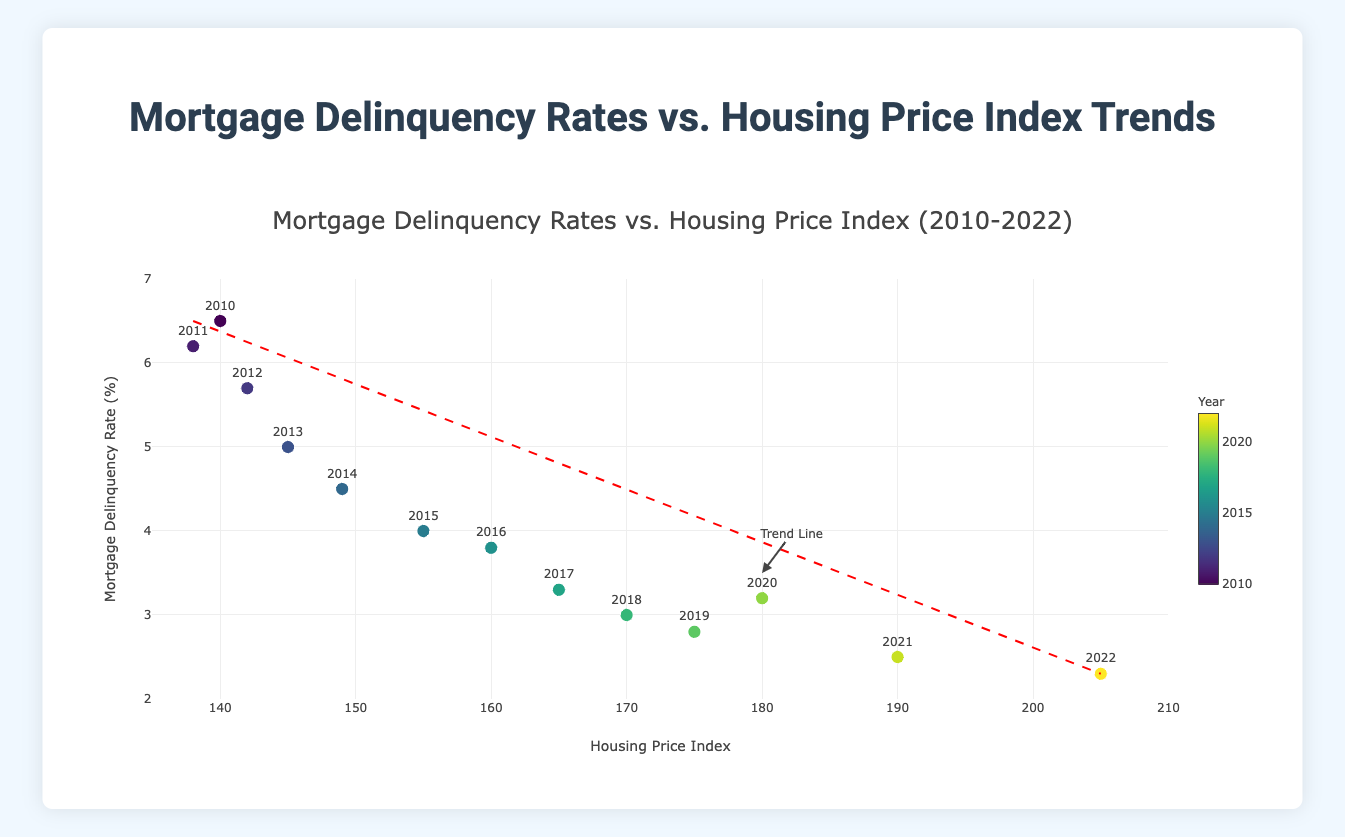What is the title of the figure? The title of the figure is usually located at the top and provides a clear description of what the plot represents. In this case, the title indicates that the figure shows the relationship between Mortgage Delinquency Rates and Housing Price Index Trends from 2010 to 2022.
Answer: Mortgage Delinquency Rates vs. Housing Price Index Trends How many data points are represented in the figure? By examining the number of markers on the scatter plot, we can count the distinct data points. Each marker corresponds to a year within the specified range.
Answer: 13 What is the Mortgage Delinquency Rate in 2016? Locate the data point corresponding to the year 2016, then read the value on the y-axis, which represents the Mortgage Delinquency Rate.
Answer: 3.8% How does the Housing Price Index change from 2010 to 2022? Identify the data points for the years 2010 and 2022. Then compare the x-axis values for these years to determine the change. The Housing Price Index increases from 140.0 in 2010 to 205.0 in 2022.
Answer: Increased Which year had the lowest Mortgage Delinquency Rate? Identify the data point that is the lowest on the y-axis, then refer to the corresponding year marked on the scatter plot.
Answer: 2022 What is the trend line showing about the relationship between Mortgage Delinquency Rates and Housing Price Index? The trend line is a dashed red line that gives the overall trend direction. It shows a downward slope from a high Mortgage Delinquency Rate to a lower one as the Housing Price Index increases, indicating an inverse relationship.
Answer: Inverse relationship In which year does the Housing Price Index first exceed 150? Identify the point where the x-axis value exceeds 150 for the first time, then find the corresponding year. This occurs at the data point for the year 2015 where the Housing Price Index is 155.0.
Answer: 2015 Which year saw an increase in Mortgage Delinquency Rate compared to the previous year? Examine the data points to find where there is an upward movement in the y-axis values from one year to the next. This occurs between 2019 and 2020.
Answer: 2020 Is there a positive or negative correlation between Mortgage Delinquency Rates and Housing Price Index based on the scatter plot? The trend line slopes downwards as the Housing Price Index increases, indicating a negative correlation between these two variables.
Answer: Negative By how much does the Mortgage Delinquency Rate decrease from 2010 to 2022? Take the Mortgage Delinquency Rate value in 2010 (6.5%) and subtract the value from 2022 (2.3%) to calculate the decrease. (6.5 - 2.3 = 4.2)
Answer: 4.2% 